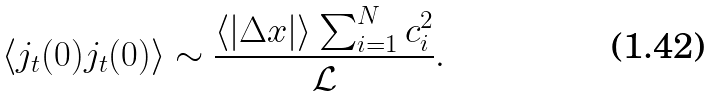Convert formula to latex. <formula><loc_0><loc_0><loc_500><loc_500>\langle j _ { t } ( 0 ) j _ { t } ( 0 ) \rangle \sim \frac { \langle | \Delta x | \rangle \sum _ { i = 1 } ^ { N } c _ { i } ^ { 2 } } { \mathcal { L } } .</formula> 